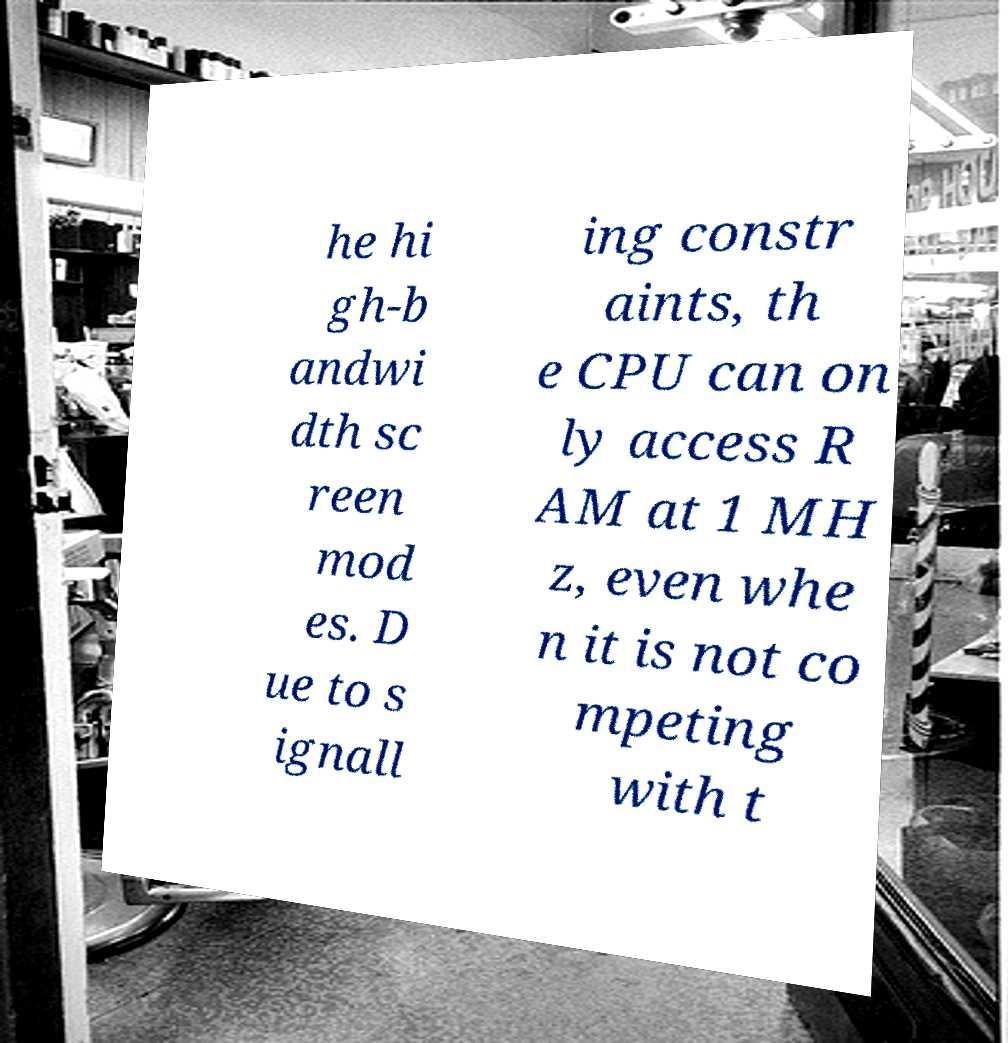Please identify and transcribe the text found in this image. he hi gh-b andwi dth sc reen mod es. D ue to s ignall ing constr aints, th e CPU can on ly access R AM at 1 MH z, even whe n it is not co mpeting with t 